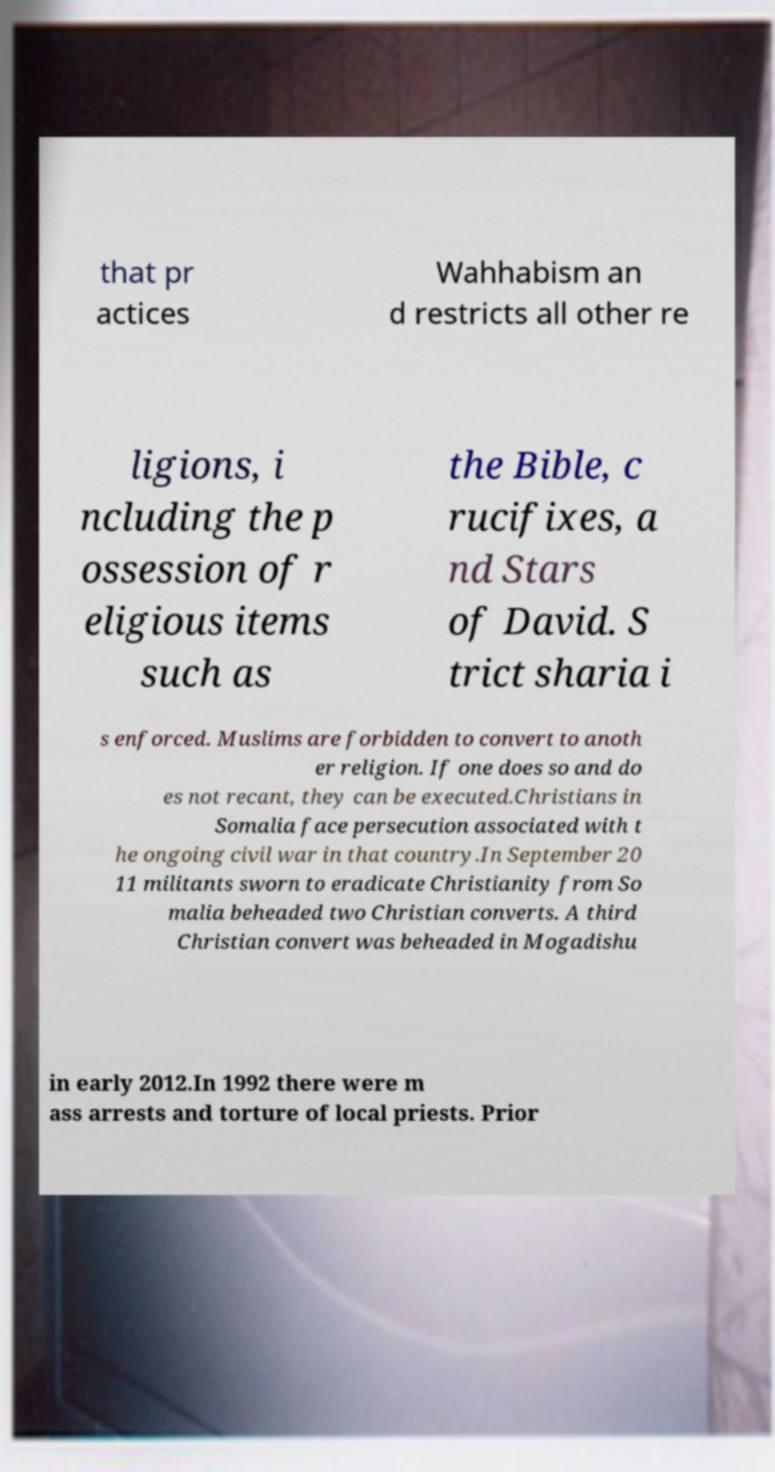For documentation purposes, I need the text within this image transcribed. Could you provide that? that pr actices Wahhabism an d restricts all other re ligions, i ncluding the p ossession of r eligious items such as the Bible, c rucifixes, a nd Stars of David. S trict sharia i s enforced. Muslims are forbidden to convert to anoth er religion. If one does so and do es not recant, they can be executed.Christians in Somalia face persecution associated with t he ongoing civil war in that country.In September 20 11 militants sworn to eradicate Christianity from So malia beheaded two Christian converts. A third Christian convert was beheaded in Mogadishu in early 2012.In 1992 there were m ass arrests and torture of local priests. Prior 